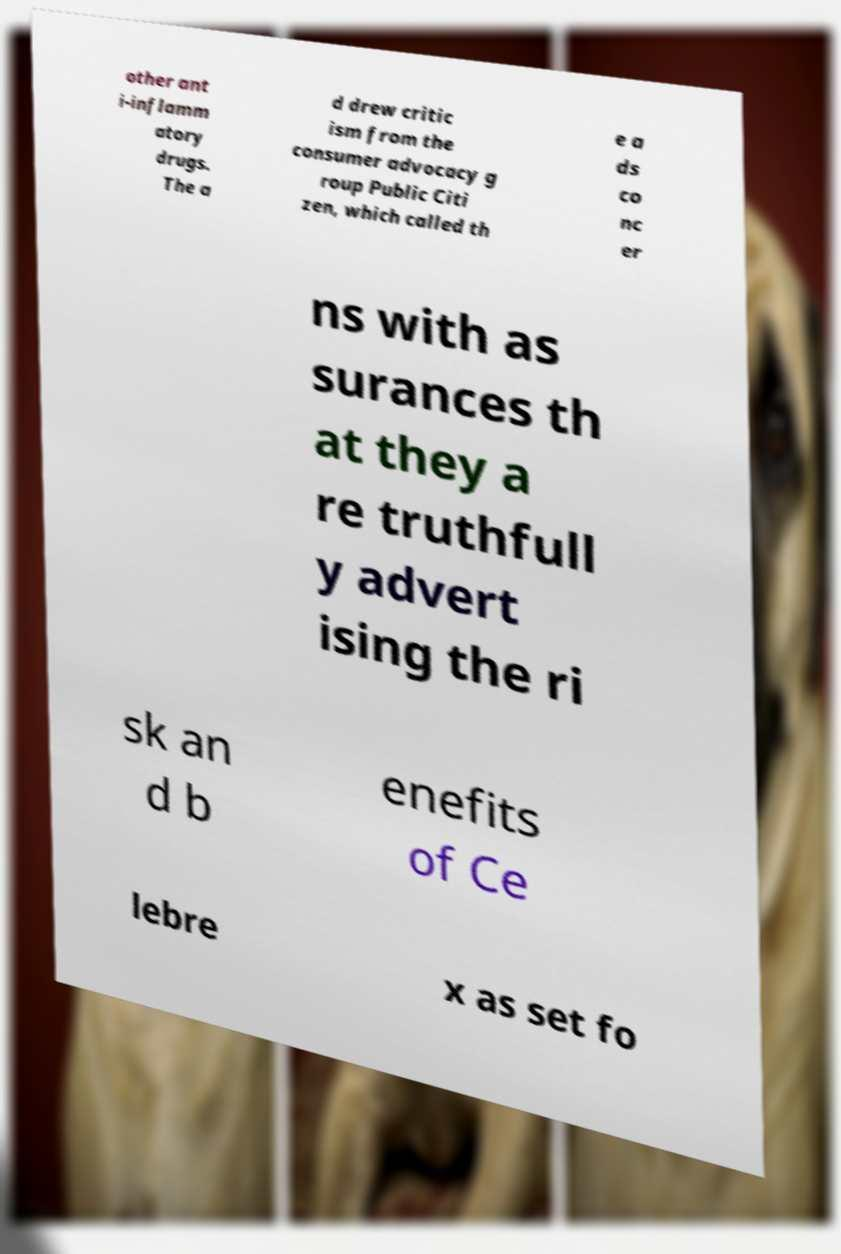Can you accurately transcribe the text from the provided image for me? other ant i-inflamm atory drugs. The a d drew critic ism from the consumer advocacy g roup Public Citi zen, which called th e a ds co nc er ns with as surances th at they a re truthfull y advert ising the ri sk an d b enefits of Ce lebre x as set fo 